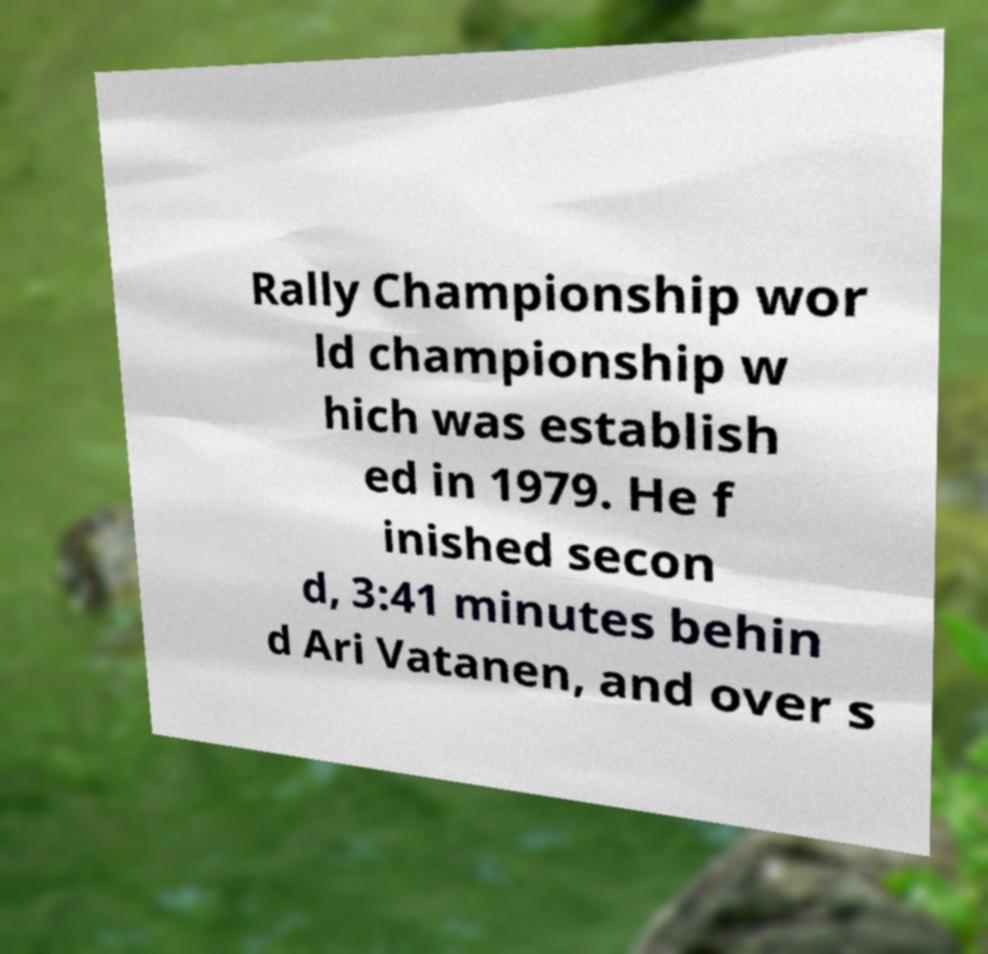Please read and relay the text visible in this image. What does it say? Rally Championship wor ld championship w hich was establish ed in 1979. He f inished secon d, 3:41 minutes behin d Ari Vatanen, and over s 